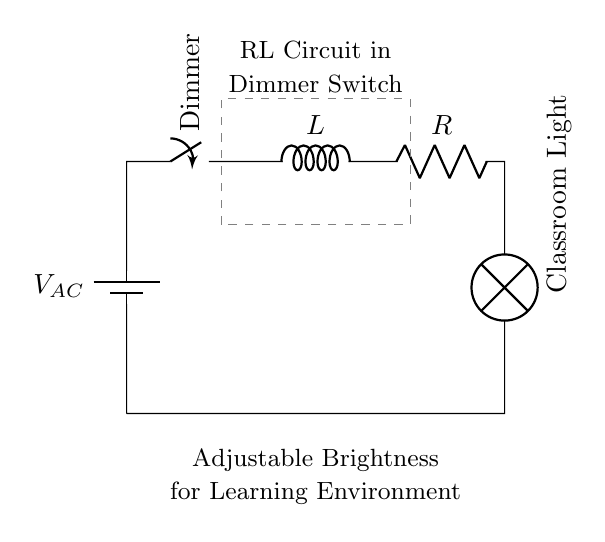What type of circuit is this? This circuit consists of a resistor and an inductor, thus it is classified as an RL circuit.
Answer: RL circuit What component controls the brightness of the light? The dimmer switch adjusts the resistance in the circuit, which in turn affects the current flowing through the inductor and the light.
Answer: Dimmer switch What is the role of the inductor in this circuit? The inductor stores energy in its magnetic field when current flows through it. In an RL circuit, it also affects the time it takes for current changes, impacting how smoothly the light dims or brightens.
Answer: Store energy What happens to the current when the dimmer switch is adjusted? Adjusting the dimmer changes the resistance, which directly influences the amount of current flowing through the circuit; higher resistance results in lower current.
Answer: Decreases What effect does the inductor have on current change? The inductor opposes changes in current due to its property of inductance, thereby causing a delay or gradual change in the current when the dimmer is adjusted.
Answer: Opposes change What is the purpose of the lamp in the circuit? The lamp is the load that consumes power, converting electrical energy into light, and is also the component whose brightness is affected by changes in current through the dimmer switch.
Answer: Provide light 